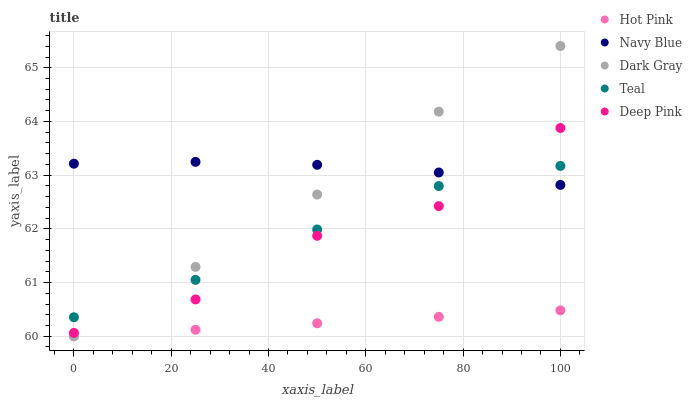Does Hot Pink have the minimum area under the curve?
Answer yes or no. Yes. Does Navy Blue have the maximum area under the curve?
Answer yes or no. Yes. Does Navy Blue have the minimum area under the curve?
Answer yes or no. No. Does Hot Pink have the maximum area under the curve?
Answer yes or no. No. Is Hot Pink the smoothest?
Answer yes or no. Yes. Is Deep Pink the roughest?
Answer yes or no. Yes. Is Navy Blue the smoothest?
Answer yes or no. No. Is Navy Blue the roughest?
Answer yes or no. No. Does Dark Gray have the lowest value?
Answer yes or no. Yes. Does Navy Blue have the lowest value?
Answer yes or no. No. Does Dark Gray have the highest value?
Answer yes or no. Yes. Does Navy Blue have the highest value?
Answer yes or no. No. Is Hot Pink less than Navy Blue?
Answer yes or no. Yes. Is Teal greater than Hot Pink?
Answer yes or no. Yes. Does Navy Blue intersect Deep Pink?
Answer yes or no. Yes. Is Navy Blue less than Deep Pink?
Answer yes or no. No. Is Navy Blue greater than Deep Pink?
Answer yes or no. No. Does Hot Pink intersect Navy Blue?
Answer yes or no. No. 